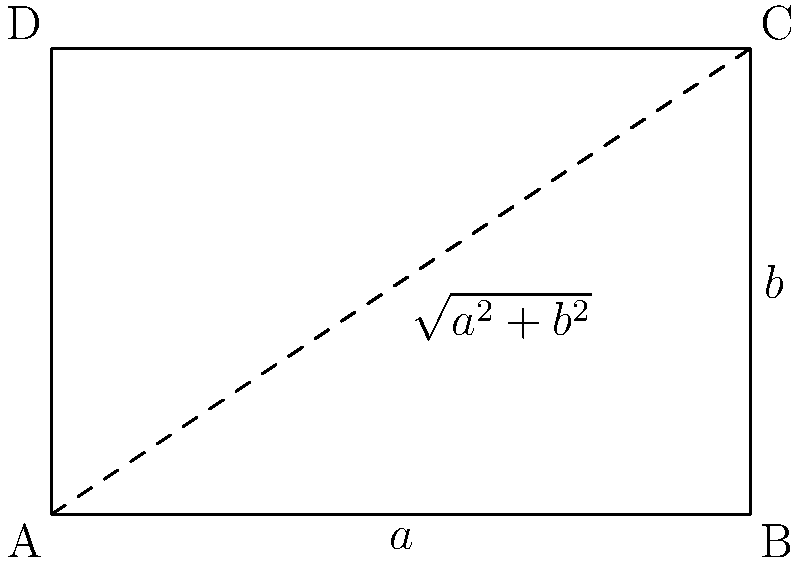You are planning an urban hunting route in a rectangular area measuring $a$ units wide and $b$ units long. To maximize efficiency, you decide to traverse the area diagonally. If $a=3$ units and $b=2$ units, determine the optimal path length to cover the entire area. Additionally, find the angle $\theta$ (in degrees) that this optimal path makes with the horizontal side of the rectangle. Let's approach this step-by-step:

1) The optimal path is the diagonal of the rectangle, as it covers the entire area in the shortest distance.

2) We can use the Pythagorean theorem to calculate the length of the diagonal:
   $$\text{Diagonal length} = \sqrt{a^2 + b^2}$$

3) Substituting the given values:
   $$\text{Diagonal length} = \sqrt{3^2 + 2^2} = \sqrt{9 + 4} = \sqrt{13}$$

4) To find the angle $\theta$, we can use the arctangent function:
   $$\theta = \arctan(\frac{b}{a})$$

5) Substituting the values:
   $$\theta = \arctan(\frac{2}{3})$$

6) Converting to degrees:
   $$\theta = \arctan(\frac{2}{3}) \cdot \frac{180}{\pi} \approx 33.69^\circ$$

Therefore, the optimal path length is $\sqrt{13}$ units, and it makes an angle of approximately 33.69° with the horizontal side.
Answer: $\sqrt{13}$ units; $33.69^\circ$ 